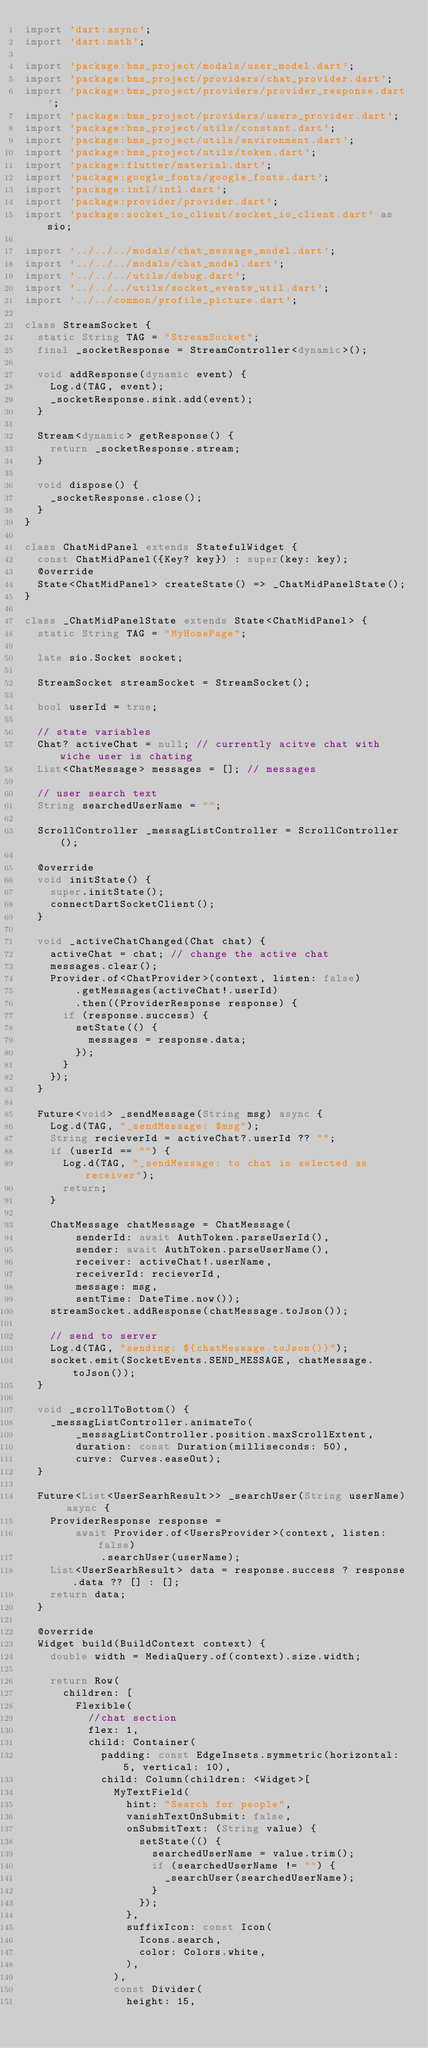<code> <loc_0><loc_0><loc_500><loc_500><_Dart_>import 'dart:async';
import 'dart:math';

import 'package:bms_project/modals/user_model.dart';
import 'package:bms_project/providers/chat_provider.dart';
import 'package:bms_project/providers/provider_response.dart';
import 'package:bms_project/providers/users_provider.dart';
import 'package:bms_project/utils/constant.dart';
import 'package:bms_project/utils/environment.dart';
import 'package:bms_project/utils/token.dart';
import 'package:flutter/material.dart';
import 'package:google_fonts/google_fonts.dart';
import 'package:intl/intl.dart';
import 'package:provider/provider.dart';
import 'package:socket_io_client/socket_io_client.dart' as sio;

import '../../../modals/chat_message_model.dart';
import '../../../modals/chat_model.dart';
import '../../../utils/debug.dart';
import '../../../utils/socket_events_util.dart';
import '../../common/profile_picture.dart';

class StreamSocket {
  static String TAG = "StreamSocket";
  final _socketResponse = StreamController<dynamic>();

  void addResponse(dynamic event) {
    Log.d(TAG, event);
    _socketResponse.sink.add(event);
  }

  Stream<dynamic> getResponse() {
    return _socketResponse.stream;
  }

  void dispose() {
    _socketResponse.close();
  }
}

class ChatMidPanel extends StatefulWidget {
  const ChatMidPanel({Key? key}) : super(key: key);
  @override
  State<ChatMidPanel> createState() => _ChatMidPanelState();
}

class _ChatMidPanelState extends State<ChatMidPanel> {
  static String TAG = "MyHomePage";

  late sio.Socket socket;

  StreamSocket streamSocket = StreamSocket();

  bool userId = true;

  // state variables
  Chat? activeChat = null; // currently acitve chat with wiche user is chating
  List<ChatMessage> messages = []; // messages

  // user search text
  String searchedUserName = "";

  ScrollController _messagListController = ScrollController();

  @override
  void initState() {
    super.initState();
    connectDartSocketClient();
  }

  void _activeChatChanged(Chat chat) {
    activeChat = chat; // change the active chat
    messages.clear();
    Provider.of<ChatProvider>(context, listen: false)
        .getMessages(activeChat!.userId)
        .then((ProviderResponse response) {
      if (response.success) {
        setState(() {
          messages = response.data;
        });
      }
    });
  }

  Future<void> _sendMessage(String msg) async {
    Log.d(TAG, "_sendMessage: $msg");
    String recieverId = activeChat?.userId ?? "";
    if (userId == "") {
      Log.d(TAG, "_sendMessage: to chat is selected as receiver");
      return;
    }

    ChatMessage chatMessage = ChatMessage(
        senderId: await AuthToken.parseUserId(),
        sender: await AuthToken.parseUserName(),
        receiver: activeChat!.userName,
        receiverId: recieverId,
        message: msg,
        sentTime: DateTime.now());
    streamSocket.addResponse(chatMessage.toJson());

    // send to server
    Log.d(TAG, "sending: ${chatMessage.toJson()}");
    socket.emit(SocketEvents.SEND_MESSAGE, chatMessage.toJson());
  }

  void _scrollToBottom() {
    _messagListController.animateTo(
        _messagListController.position.maxScrollExtent,
        duration: const Duration(milliseconds: 50),
        curve: Curves.easeOut);
  }

  Future<List<UserSearhResult>> _searchUser(String userName) async {
    ProviderResponse response =
        await Provider.of<UsersProvider>(context, listen: false)
            .searchUser(userName);
    List<UserSearhResult> data = response.success ? response.data ?? [] : [];
    return data;
  }

  @override
  Widget build(BuildContext context) {
    double width = MediaQuery.of(context).size.width;

    return Row(
      children: [
        Flexible(
          //chat section
          flex: 1,
          child: Container(
            padding: const EdgeInsets.symmetric(horizontal: 5, vertical: 10),
            child: Column(children: <Widget>[
              MyTextField(
                hint: "Search for people",
                vanishTextOnSubmit: false,
                onSubmitText: (String value) {
                  setState(() {
                    searchedUserName = value.trim();
                    if (searchedUserName != "") {
                      _searchUser(searchedUserName);
                    }
                  });
                },
                suffixIcon: const Icon(
                  Icons.search,
                  color: Colors.white,
                ),
              ),
              const Divider(
                height: 15,</code> 